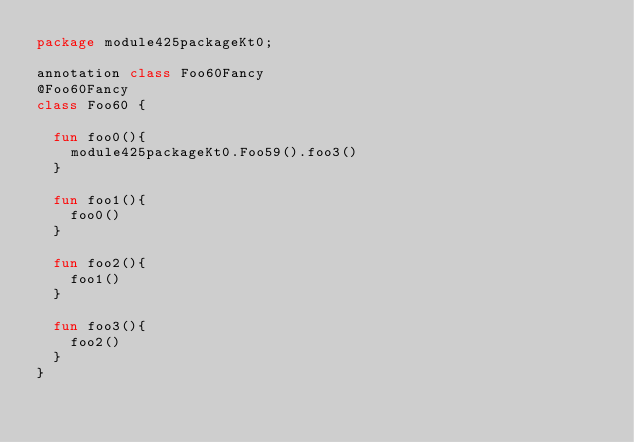<code> <loc_0><loc_0><loc_500><loc_500><_Kotlin_>package module425packageKt0;

annotation class Foo60Fancy
@Foo60Fancy
class Foo60 {

  fun foo0(){
    module425packageKt0.Foo59().foo3()
  }

  fun foo1(){
    foo0()
  }

  fun foo2(){
    foo1()
  }

  fun foo3(){
    foo2()
  }
}</code> 